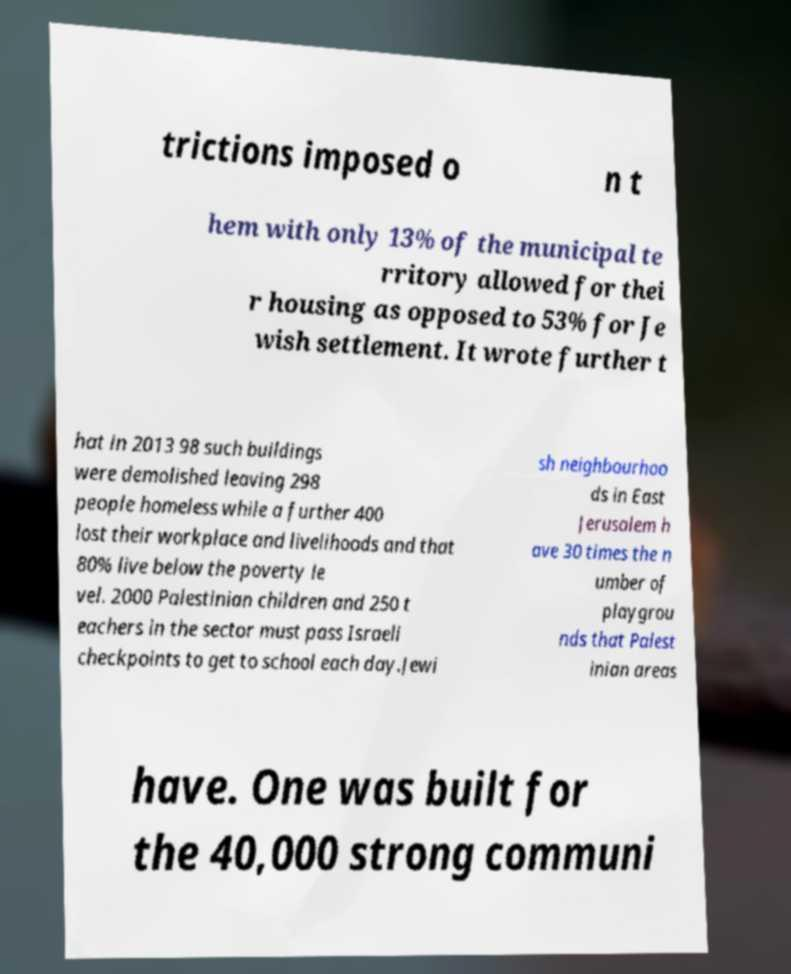Could you extract and type out the text from this image? trictions imposed o n t hem with only 13% of the municipal te rritory allowed for thei r housing as opposed to 53% for Je wish settlement. It wrote further t hat in 2013 98 such buildings were demolished leaving 298 people homeless while a further 400 lost their workplace and livelihoods and that 80% live below the poverty le vel. 2000 Palestinian children and 250 t eachers in the sector must pass Israeli checkpoints to get to school each day.Jewi sh neighbourhoo ds in East Jerusalem h ave 30 times the n umber of playgrou nds that Palest inian areas have. One was built for the 40,000 strong communi 